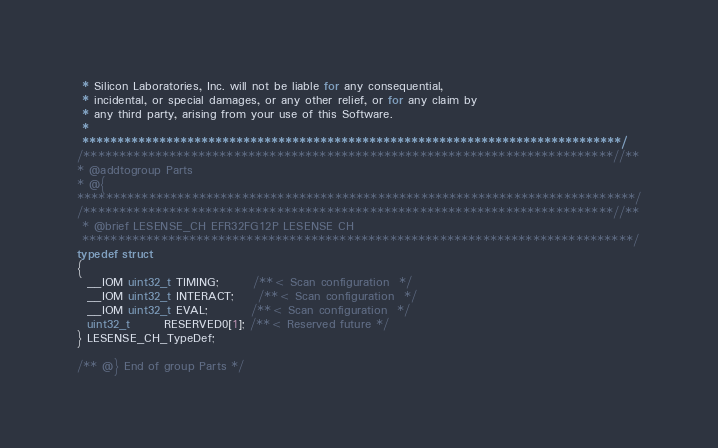Convert code to text. <code><loc_0><loc_0><loc_500><loc_500><_C_> * Silicon Laboratories, Inc. will not be liable for any consequential,
 * incidental, or special damages, or any other relief, or for any claim by
 * any third party, arising from your use of this Software.
 *
 *****************************************************************************/
/**************************************************************************//**
* @addtogroup Parts
* @{
******************************************************************************/
/**************************************************************************//**
 * @brief LESENSE_CH EFR32FG12P LESENSE CH
 *****************************************************************************/
typedef struct
{
  __IOM uint32_t TIMING;       /**< Scan configuration  */
  __IOM uint32_t INTERACT;     /**< Scan configuration  */
  __IOM uint32_t EVAL;         /**< Scan configuration  */
  uint32_t       RESERVED0[1]; /**< Reserved future */
} LESENSE_CH_TypeDef;

/** @} End of group Parts */


</code> 